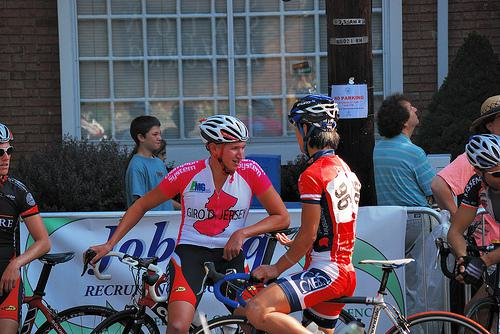Describe the atmosphere of the event shown in the image. The atmosphere appears lively and competitive, characteristic of cycling events. Spectators along the road and the presence of banners suggest that this is a well-attended event, possibly part of a larger tournament or celebration of cycling. The bright, sunny day further adds to the vibrant setting of the race. 